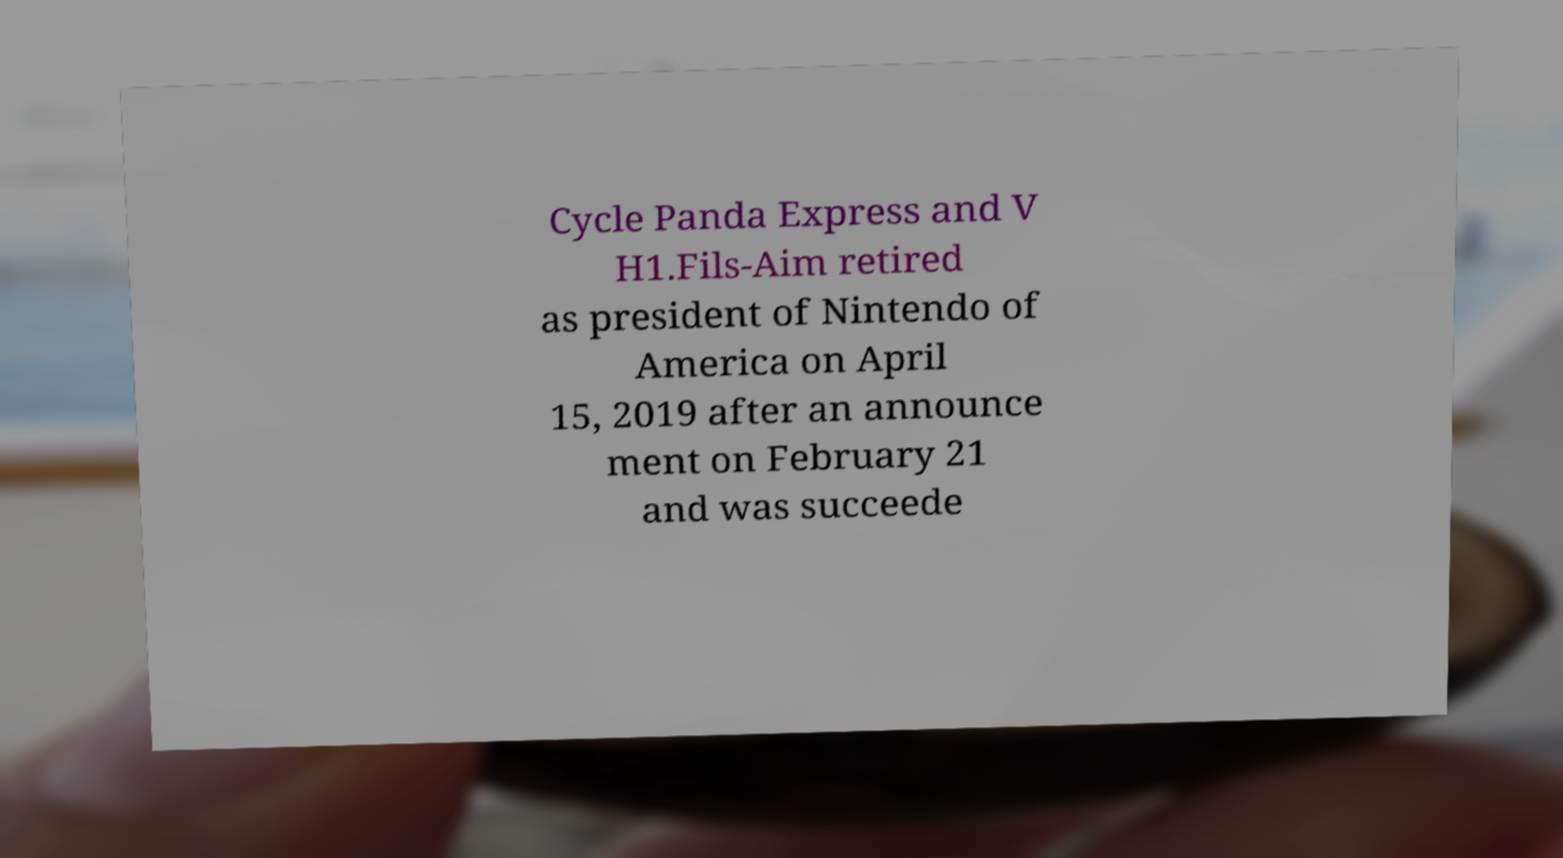Can you accurately transcribe the text from the provided image for me? Cycle Panda Express and V H1.Fils-Aim retired as president of Nintendo of America on April 15, 2019 after an announce ment on February 21 and was succeede 